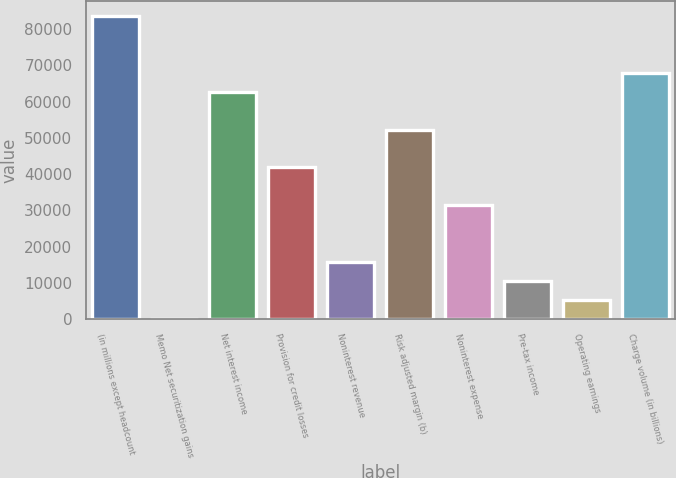Convert chart to OTSL. <chart><loc_0><loc_0><loc_500><loc_500><bar_chart><fcel>(in millions except headcount<fcel>Memo Net securitization gains<fcel>Net interest income<fcel>Provision for credit losses<fcel>Noninterest revenue<fcel>Risk adjusted margin (b)<fcel>Noninterest expense<fcel>Pre-tax income<fcel>Operating earnings<fcel>Charge volume (in billions)<nl><fcel>83650.6<fcel>1<fcel>62738.2<fcel>41825.8<fcel>15685.3<fcel>52282<fcel>31369.6<fcel>10457.2<fcel>5229.1<fcel>67966.3<nl></chart> 